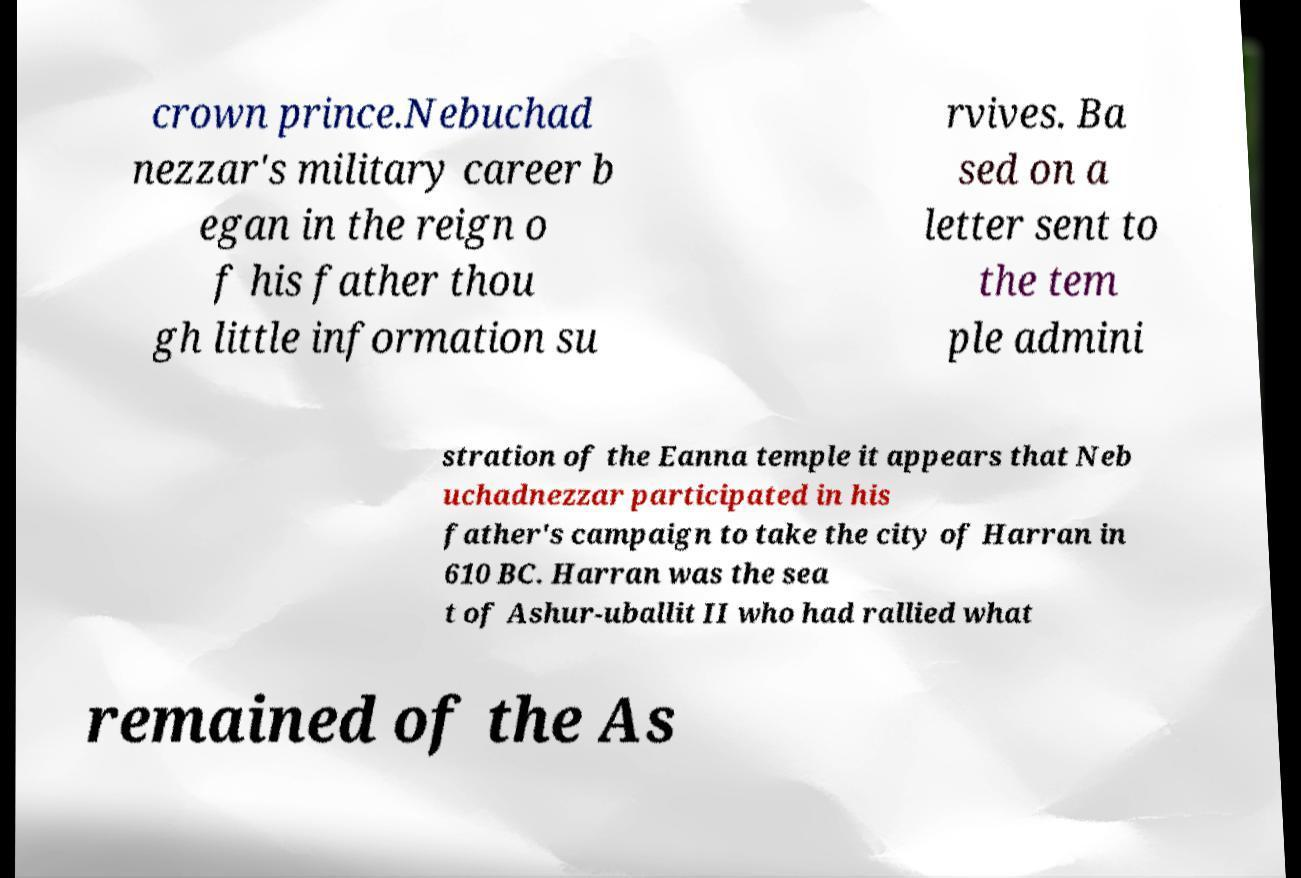Please read and relay the text visible in this image. What does it say? crown prince.Nebuchad nezzar's military career b egan in the reign o f his father thou gh little information su rvives. Ba sed on a letter sent to the tem ple admini stration of the Eanna temple it appears that Neb uchadnezzar participated in his father's campaign to take the city of Harran in 610 BC. Harran was the sea t of Ashur-uballit II who had rallied what remained of the As 